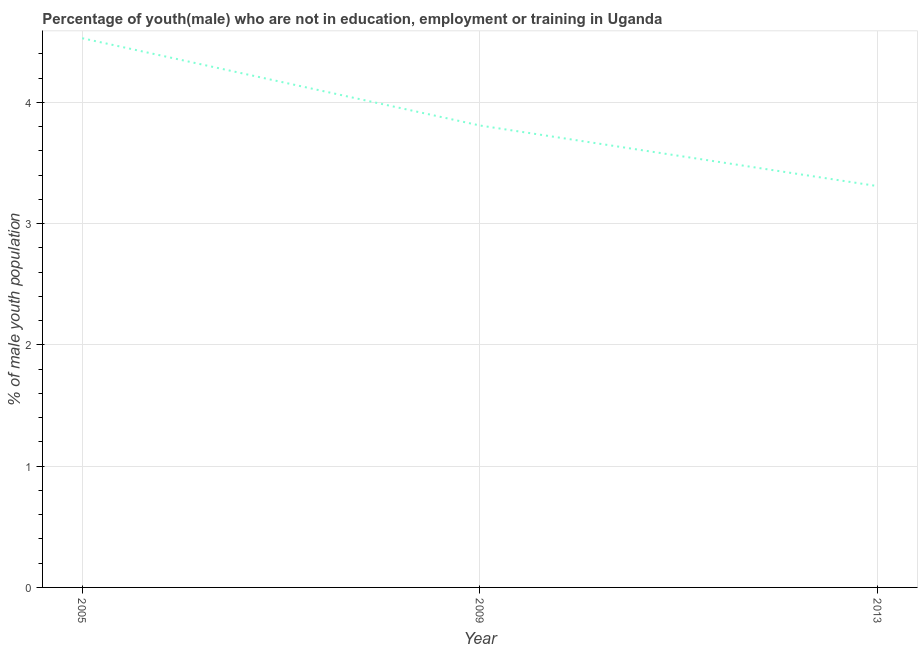What is the unemployed male youth population in 2005?
Offer a terse response. 4.53. Across all years, what is the maximum unemployed male youth population?
Ensure brevity in your answer.  4.53. Across all years, what is the minimum unemployed male youth population?
Provide a short and direct response. 3.31. In which year was the unemployed male youth population maximum?
Keep it short and to the point. 2005. In which year was the unemployed male youth population minimum?
Give a very brief answer. 2013. What is the sum of the unemployed male youth population?
Give a very brief answer. 11.65. What is the difference between the unemployed male youth population in 2005 and 2009?
Keep it short and to the point. 0.72. What is the average unemployed male youth population per year?
Ensure brevity in your answer.  3.88. What is the median unemployed male youth population?
Your answer should be very brief. 3.81. In how many years, is the unemployed male youth population greater than 0.2 %?
Offer a terse response. 3. Do a majority of the years between 2013 and 2005 (inclusive) have unemployed male youth population greater than 3.6 %?
Offer a very short reply. No. What is the ratio of the unemployed male youth population in 2005 to that in 2013?
Provide a short and direct response. 1.37. Is the unemployed male youth population in 2009 less than that in 2013?
Provide a succinct answer. No. What is the difference between the highest and the second highest unemployed male youth population?
Ensure brevity in your answer.  0.72. Is the sum of the unemployed male youth population in 2009 and 2013 greater than the maximum unemployed male youth population across all years?
Your answer should be compact. Yes. What is the difference between the highest and the lowest unemployed male youth population?
Your response must be concise. 1.22. Does the unemployed male youth population monotonically increase over the years?
Your response must be concise. No. How many lines are there?
Give a very brief answer. 1. What is the difference between two consecutive major ticks on the Y-axis?
Your answer should be very brief. 1. Are the values on the major ticks of Y-axis written in scientific E-notation?
Your response must be concise. No. Does the graph contain any zero values?
Your answer should be compact. No. Does the graph contain grids?
Ensure brevity in your answer.  Yes. What is the title of the graph?
Provide a short and direct response. Percentage of youth(male) who are not in education, employment or training in Uganda. What is the label or title of the X-axis?
Make the answer very short. Year. What is the label or title of the Y-axis?
Provide a short and direct response. % of male youth population. What is the % of male youth population of 2005?
Keep it short and to the point. 4.53. What is the % of male youth population in 2009?
Make the answer very short. 3.81. What is the % of male youth population in 2013?
Provide a succinct answer. 3.31. What is the difference between the % of male youth population in 2005 and 2009?
Your response must be concise. 0.72. What is the difference between the % of male youth population in 2005 and 2013?
Your answer should be very brief. 1.22. What is the difference between the % of male youth population in 2009 and 2013?
Make the answer very short. 0.5. What is the ratio of the % of male youth population in 2005 to that in 2009?
Your response must be concise. 1.19. What is the ratio of the % of male youth population in 2005 to that in 2013?
Provide a short and direct response. 1.37. What is the ratio of the % of male youth population in 2009 to that in 2013?
Your answer should be compact. 1.15. 